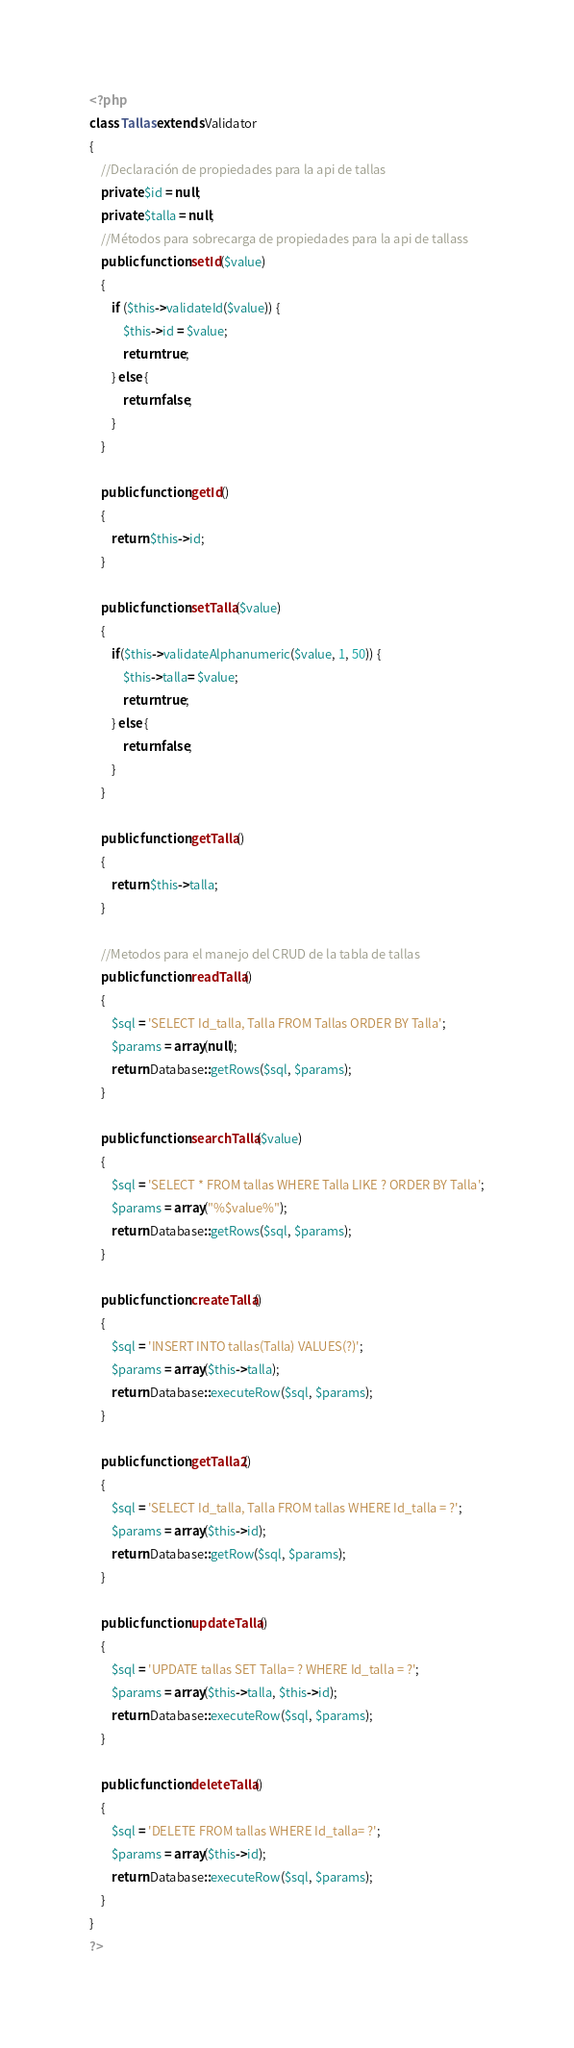<code> <loc_0><loc_0><loc_500><loc_500><_PHP_><?php
class Tallas extends Validator
{
	//Declaración de propiedades para la api de tallas
	private $id = null;
	private $talla = null;
	//Métodos para sobrecarga de propiedades para la api de tallass
	public function setId($value)
	{
		if ($this->validateId($value)) {
			$this->id = $value;
			return true;
		} else {
			return false;
		}
	}

	public function getId()
	{
		return $this->id;
	}

	public function setTalla($value)
	{
		if($this->validateAlphanumeric($value, 1, 50)) {
			$this->talla= $value;
			return true;
		} else {
			return false;
		}
	}

	public function getTalla()
	{
		return $this->talla;
	}

	//Metodos para el manejo del CRUD de la tabla de tallas
	public function readTalla()
	{
		$sql = 'SELECT Id_talla, Talla FROM Tallas ORDER BY Talla';
		$params = array(null);
		return Database::getRows($sql, $params);
	}

	public function searchTalla($value)
	{
		$sql = 'SELECT * FROM tallas WHERE Talla LIKE ? ORDER BY Talla';
		$params = array("%$value%");
		return Database::getRows($sql, $params);
	}

	public function createTalla()
	{
		$sql = 'INSERT INTO tallas(Talla) VALUES(?)';
		$params = array($this->talla);
		return Database::executeRow($sql, $params);
	}

	public function getTalla2()
	{
		$sql = 'SELECT Id_talla, Talla FROM tallas WHERE Id_talla = ?';
		$params = array($this->id);
		return Database::getRow($sql, $params);
	}

	public function updateTalla()
	{
		$sql = 'UPDATE tallas SET Talla= ? WHERE Id_talla = ?';
		$params = array($this->talla, $this->id);
		return Database::executeRow($sql, $params);
	}

	public function deleteTalla()
	{
		$sql = 'DELETE FROM tallas WHERE Id_talla= ?';
		$params = array($this->id);
		return Database::executeRow($sql, $params);
	}
}
?>
</code> 